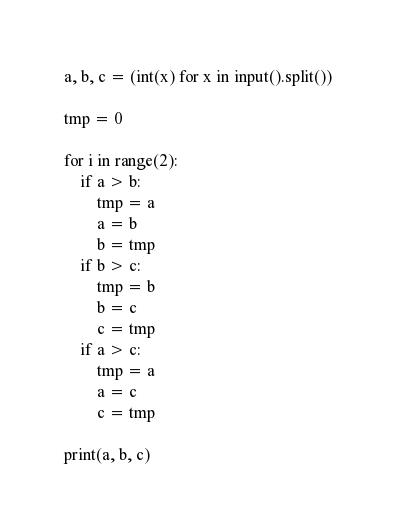<code> <loc_0><loc_0><loc_500><loc_500><_Python_>a, b, c = (int(x) for x in input().split())

tmp = 0

for i in range(2):
    if a > b:
        tmp = a
        a = b
        b = tmp
    if b > c:
        tmp = b
        b = c
        c = tmp
    if a > c:
        tmp = a
        a = c
        c = tmp

print(a, b, c)

</code> 